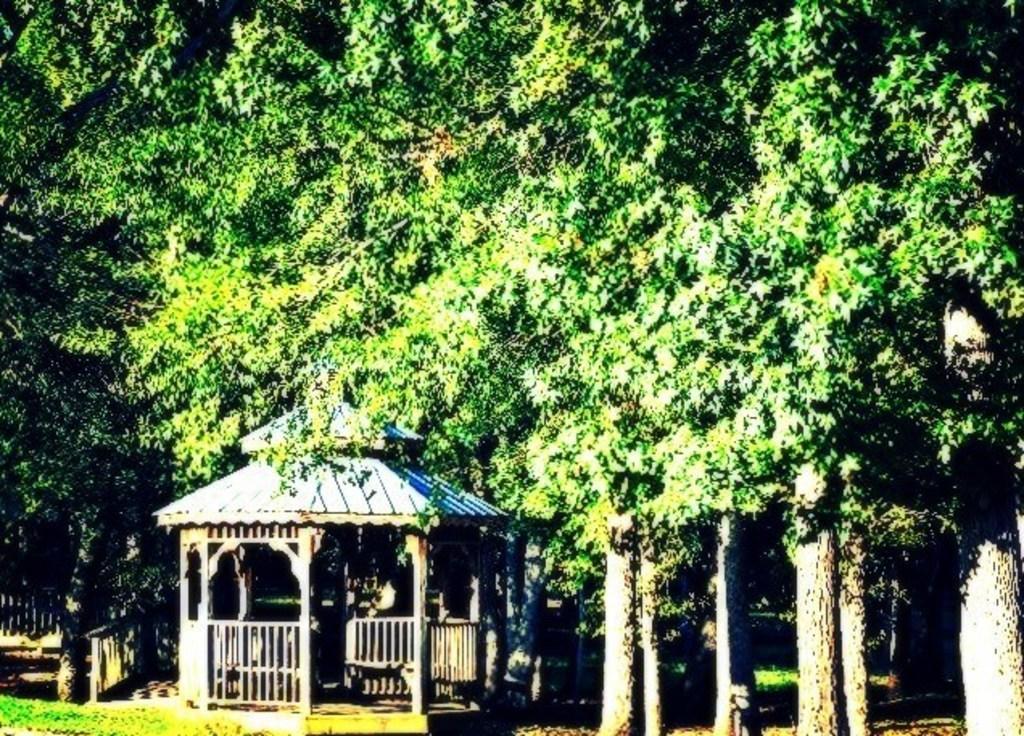In one or two sentences, can you explain what this image depicts? In this image in the center there is one house and a fence, and in the background there are some trees and at the bottom there is grass. 